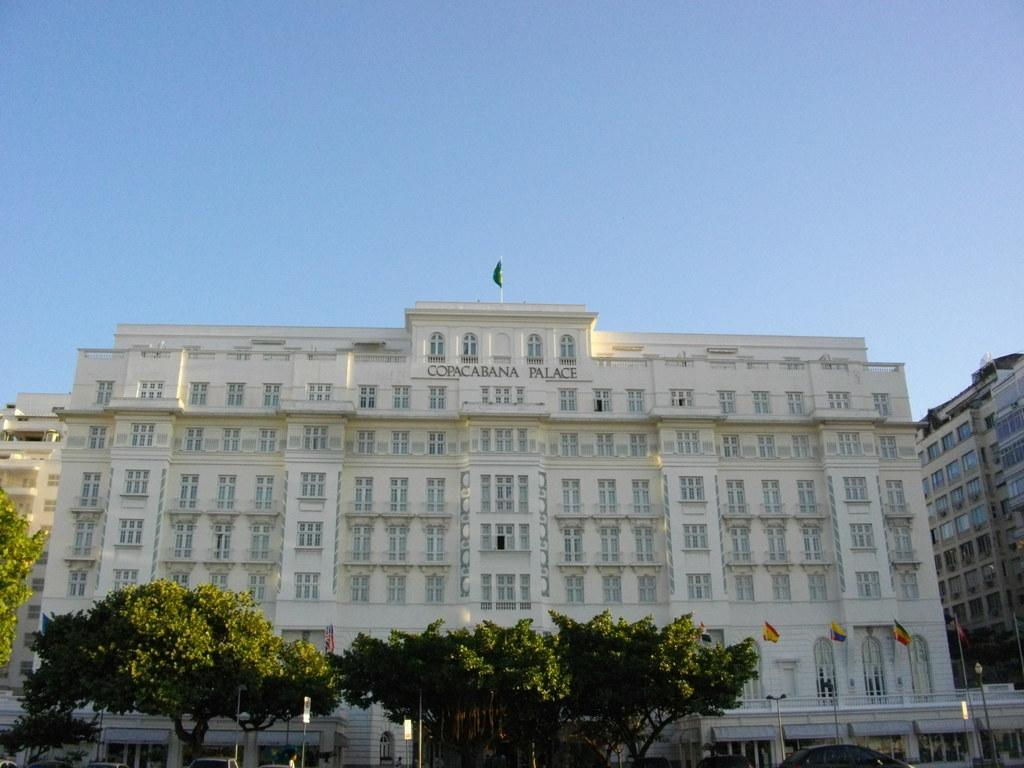What type of structures can be seen in the image? There are buildings in the image. What is located in front of the buildings? There are trees in front of the buildings. What other objects can be seen in the image? There are flags and vehicles in the image. What type of blade can be seen cutting through the trees in the image? There is no blade present in the image, and the trees are not being cut. 